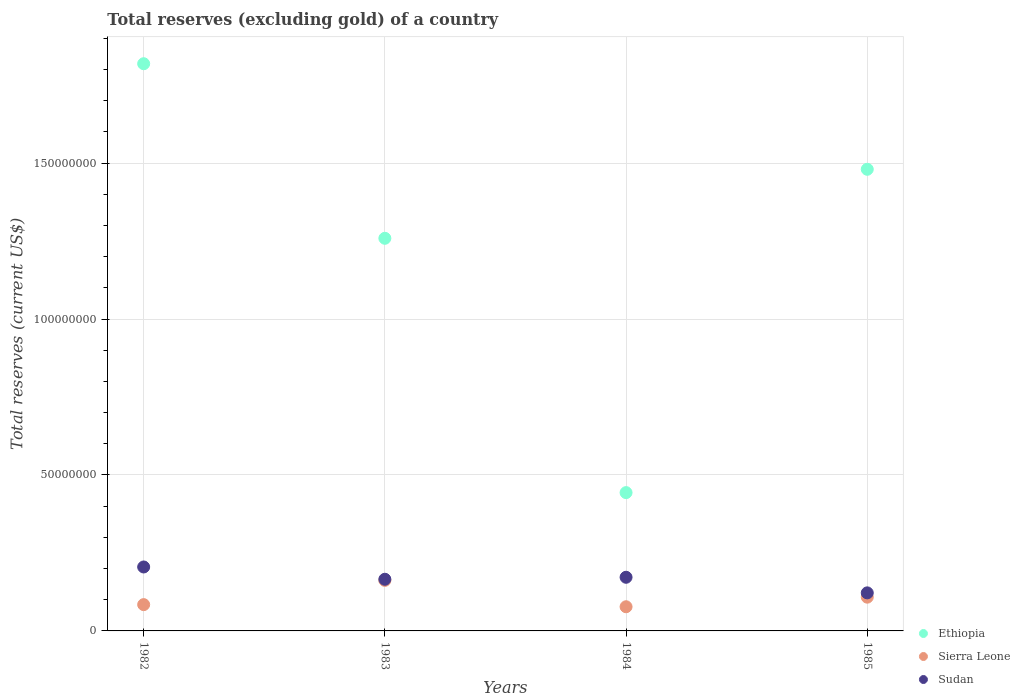How many different coloured dotlines are there?
Ensure brevity in your answer.  3. What is the total reserves (excluding gold) in Ethiopia in 1984?
Provide a succinct answer. 4.43e+07. Across all years, what is the maximum total reserves (excluding gold) in Sudan?
Give a very brief answer. 2.05e+07. Across all years, what is the minimum total reserves (excluding gold) in Sudan?
Provide a succinct answer. 1.22e+07. What is the total total reserves (excluding gold) in Sierra Leone in the graph?
Give a very brief answer. 4.32e+07. What is the difference between the total reserves (excluding gold) in Sudan in 1982 and that in 1984?
Your response must be concise. 3.30e+06. What is the difference between the total reserves (excluding gold) in Ethiopia in 1984 and the total reserves (excluding gold) in Sierra Leone in 1983?
Ensure brevity in your answer.  2.81e+07. What is the average total reserves (excluding gold) in Sierra Leone per year?
Make the answer very short. 1.08e+07. In the year 1982, what is the difference between the total reserves (excluding gold) in Sudan and total reserves (excluding gold) in Sierra Leone?
Ensure brevity in your answer.  1.21e+07. In how many years, is the total reserves (excluding gold) in Ethiopia greater than 110000000 US$?
Ensure brevity in your answer.  3. What is the ratio of the total reserves (excluding gold) in Sudan in 1984 to that in 1985?
Your answer should be compact. 1.41. Is the total reserves (excluding gold) in Ethiopia in 1982 less than that in 1983?
Ensure brevity in your answer.  No. Is the difference between the total reserves (excluding gold) in Sudan in 1983 and 1984 greater than the difference between the total reserves (excluding gold) in Sierra Leone in 1983 and 1984?
Keep it short and to the point. No. What is the difference between the highest and the second highest total reserves (excluding gold) in Sierra Leone?
Keep it short and to the point. 5.38e+06. What is the difference between the highest and the lowest total reserves (excluding gold) in Sudan?
Your answer should be compact. 8.30e+06. Is the sum of the total reserves (excluding gold) in Sudan in 1983 and 1984 greater than the maximum total reserves (excluding gold) in Sierra Leone across all years?
Keep it short and to the point. Yes. Is it the case that in every year, the sum of the total reserves (excluding gold) in Ethiopia and total reserves (excluding gold) in Sierra Leone  is greater than the total reserves (excluding gold) in Sudan?
Provide a succinct answer. Yes. Does the total reserves (excluding gold) in Sudan monotonically increase over the years?
Provide a short and direct response. No. Is the total reserves (excluding gold) in Sierra Leone strictly greater than the total reserves (excluding gold) in Sudan over the years?
Keep it short and to the point. No. How many dotlines are there?
Give a very brief answer. 3. How many years are there in the graph?
Your answer should be very brief. 4. Are the values on the major ticks of Y-axis written in scientific E-notation?
Your answer should be very brief. No. Does the graph contain any zero values?
Offer a terse response. No. Does the graph contain grids?
Give a very brief answer. Yes. Where does the legend appear in the graph?
Make the answer very short. Bottom right. How are the legend labels stacked?
Your response must be concise. Vertical. What is the title of the graph?
Offer a very short reply. Total reserves (excluding gold) of a country. Does "Philippines" appear as one of the legend labels in the graph?
Offer a very short reply. No. What is the label or title of the Y-axis?
Give a very brief answer. Total reserves (current US$). What is the Total reserves (current US$) of Ethiopia in 1982?
Your answer should be very brief. 1.82e+08. What is the Total reserves (current US$) in Sierra Leone in 1982?
Ensure brevity in your answer.  8.43e+06. What is the Total reserves (current US$) of Sudan in 1982?
Provide a succinct answer. 2.05e+07. What is the Total reserves (current US$) of Ethiopia in 1983?
Keep it short and to the point. 1.26e+08. What is the Total reserves (current US$) of Sierra Leone in 1983?
Provide a succinct answer. 1.62e+07. What is the Total reserves (current US$) of Sudan in 1983?
Offer a very short reply. 1.66e+07. What is the Total reserves (current US$) of Ethiopia in 1984?
Provide a succinct answer. 4.43e+07. What is the Total reserves (current US$) of Sierra Leone in 1984?
Your answer should be compact. 7.75e+06. What is the Total reserves (current US$) in Sudan in 1984?
Make the answer very short. 1.72e+07. What is the Total reserves (current US$) in Ethiopia in 1985?
Ensure brevity in your answer.  1.48e+08. What is the Total reserves (current US$) in Sierra Leone in 1985?
Offer a terse response. 1.08e+07. What is the Total reserves (current US$) in Sudan in 1985?
Your response must be concise. 1.22e+07. Across all years, what is the maximum Total reserves (current US$) of Ethiopia?
Offer a very short reply. 1.82e+08. Across all years, what is the maximum Total reserves (current US$) of Sierra Leone?
Ensure brevity in your answer.  1.62e+07. Across all years, what is the maximum Total reserves (current US$) in Sudan?
Ensure brevity in your answer.  2.05e+07. Across all years, what is the minimum Total reserves (current US$) of Ethiopia?
Your answer should be compact. 4.43e+07. Across all years, what is the minimum Total reserves (current US$) of Sierra Leone?
Your answer should be compact. 7.75e+06. Across all years, what is the minimum Total reserves (current US$) in Sudan?
Your answer should be compact. 1.22e+07. What is the total Total reserves (current US$) of Ethiopia in the graph?
Offer a terse response. 5.00e+08. What is the total Total reserves (current US$) in Sierra Leone in the graph?
Keep it short and to the point. 4.32e+07. What is the total Total reserves (current US$) of Sudan in the graph?
Keep it short and to the point. 6.65e+07. What is the difference between the Total reserves (current US$) in Ethiopia in 1982 and that in 1983?
Provide a short and direct response. 5.60e+07. What is the difference between the Total reserves (current US$) of Sierra Leone in 1982 and that in 1983?
Offer a terse response. -7.78e+06. What is the difference between the Total reserves (current US$) in Sudan in 1982 and that in 1983?
Provide a short and direct response. 3.94e+06. What is the difference between the Total reserves (current US$) of Ethiopia in 1982 and that in 1984?
Provide a short and direct response. 1.38e+08. What is the difference between the Total reserves (current US$) in Sierra Leone in 1982 and that in 1984?
Offer a very short reply. 6.80e+05. What is the difference between the Total reserves (current US$) in Sudan in 1982 and that in 1984?
Give a very brief answer. 3.30e+06. What is the difference between the Total reserves (current US$) in Ethiopia in 1982 and that in 1985?
Your answer should be compact. 3.38e+07. What is the difference between the Total reserves (current US$) of Sierra Leone in 1982 and that in 1985?
Give a very brief answer. -2.39e+06. What is the difference between the Total reserves (current US$) of Sudan in 1982 and that in 1985?
Provide a short and direct response. 8.30e+06. What is the difference between the Total reserves (current US$) in Ethiopia in 1983 and that in 1984?
Your answer should be compact. 8.15e+07. What is the difference between the Total reserves (current US$) in Sierra Leone in 1983 and that in 1984?
Provide a short and direct response. 8.46e+06. What is the difference between the Total reserves (current US$) of Sudan in 1983 and that in 1984?
Offer a terse response. -6.37e+05. What is the difference between the Total reserves (current US$) of Ethiopia in 1983 and that in 1985?
Your answer should be very brief. -2.21e+07. What is the difference between the Total reserves (current US$) of Sierra Leone in 1983 and that in 1985?
Provide a short and direct response. 5.38e+06. What is the difference between the Total reserves (current US$) in Sudan in 1983 and that in 1985?
Give a very brief answer. 4.36e+06. What is the difference between the Total reserves (current US$) of Ethiopia in 1984 and that in 1985?
Provide a short and direct response. -1.04e+08. What is the difference between the Total reserves (current US$) of Sierra Leone in 1984 and that in 1985?
Your answer should be compact. -3.07e+06. What is the difference between the Total reserves (current US$) in Ethiopia in 1982 and the Total reserves (current US$) in Sierra Leone in 1983?
Provide a succinct answer. 1.66e+08. What is the difference between the Total reserves (current US$) of Ethiopia in 1982 and the Total reserves (current US$) of Sudan in 1983?
Your response must be concise. 1.65e+08. What is the difference between the Total reserves (current US$) of Sierra Leone in 1982 and the Total reserves (current US$) of Sudan in 1983?
Provide a succinct answer. -8.13e+06. What is the difference between the Total reserves (current US$) of Ethiopia in 1982 and the Total reserves (current US$) of Sierra Leone in 1984?
Keep it short and to the point. 1.74e+08. What is the difference between the Total reserves (current US$) of Ethiopia in 1982 and the Total reserves (current US$) of Sudan in 1984?
Offer a terse response. 1.65e+08. What is the difference between the Total reserves (current US$) of Sierra Leone in 1982 and the Total reserves (current US$) of Sudan in 1984?
Provide a short and direct response. -8.77e+06. What is the difference between the Total reserves (current US$) of Ethiopia in 1982 and the Total reserves (current US$) of Sierra Leone in 1985?
Keep it short and to the point. 1.71e+08. What is the difference between the Total reserves (current US$) in Ethiopia in 1982 and the Total reserves (current US$) in Sudan in 1985?
Offer a very short reply. 1.70e+08. What is the difference between the Total reserves (current US$) of Sierra Leone in 1982 and the Total reserves (current US$) of Sudan in 1985?
Give a very brief answer. -3.77e+06. What is the difference between the Total reserves (current US$) of Ethiopia in 1983 and the Total reserves (current US$) of Sierra Leone in 1984?
Your answer should be compact. 1.18e+08. What is the difference between the Total reserves (current US$) in Ethiopia in 1983 and the Total reserves (current US$) in Sudan in 1984?
Your answer should be compact. 1.09e+08. What is the difference between the Total reserves (current US$) of Sierra Leone in 1983 and the Total reserves (current US$) of Sudan in 1984?
Give a very brief answer. -9.95e+05. What is the difference between the Total reserves (current US$) in Ethiopia in 1983 and the Total reserves (current US$) in Sierra Leone in 1985?
Offer a very short reply. 1.15e+08. What is the difference between the Total reserves (current US$) of Ethiopia in 1983 and the Total reserves (current US$) of Sudan in 1985?
Offer a very short reply. 1.14e+08. What is the difference between the Total reserves (current US$) of Sierra Leone in 1983 and the Total reserves (current US$) of Sudan in 1985?
Provide a succinct answer. 4.00e+06. What is the difference between the Total reserves (current US$) of Ethiopia in 1984 and the Total reserves (current US$) of Sierra Leone in 1985?
Offer a very short reply. 3.35e+07. What is the difference between the Total reserves (current US$) of Ethiopia in 1984 and the Total reserves (current US$) of Sudan in 1985?
Keep it short and to the point. 3.21e+07. What is the difference between the Total reserves (current US$) in Sierra Leone in 1984 and the Total reserves (current US$) in Sudan in 1985?
Offer a very short reply. -4.45e+06. What is the average Total reserves (current US$) in Ethiopia per year?
Provide a short and direct response. 1.25e+08. What is the average Total reserves (current US$) of Sierra Leone per year?
Ensure brevity in your answer.  1.08e+07. What is the average Total reserves (current US$) in Sudan per year?
Your answer should be very brief. 1.66e+07. In the year 1982, what is the difference between the Total reserves (current US$) in Ethiopia and Total reserves (current US$) in Sierra Leone?
Ensure brevity in your answer.  1.73e+08. In the year 1982, what is the difference between the Total reserves (current US$) in Ethiopia and Total reserves (current US$) in Sudan?
Provide a succinct answer. 1.61e+08. In the year 1982, what is the difference between the Total reserves (current US$) in Sierra Leone and Total reserves (current US$) in Sudan?
Ensure brevity in your answer.  -1.21e+07. In the year 1983, what is the difference between the Total reserves (current US$) of Ethiopia and Total reserves (current US$) of Sierra Leone?
Offer a very short reply. 1.10e+08. In the year 1983, what is the difference between the Total reserves (current US$) of Ethiopia and Total reserves (current US$) of Sudan?
Provide a short and direct response. 1.09e+08. In the year 1983, what is the difference between the Total reserves (current US$) in Sierra Leone and Total reserves (current US$) in Sudan?
Give a very brief answer. -3.58e+05. In the year 1984, what is the difference between the Total reserves (current US$) in Ethiopia and Total reserves (current US$) in Sierra Leone?
Ensure brevity in your answer.  3.66e+07. In the year 1984, what is the difference between the Total reserves (current US$) in Ethiopia and Total reserves (current US$) in Sudan?
Offer a terse response. 2.71e+07. In the year 1984, what is the difference between the Total reserves (current US$) in Sierra Leone and Total reserves (current US$) in Sudan?
Give a very brief answer. -9.45e+06. In the year 1985, what is the difference between the Total reserves (current US$) of Ethiopia and Total reserves (current US$) of Sierra Leone?
Ensure brevity in your answer.  1.37e+08. In the year 1985, what is the difference between the Total reserves (current US$) in Ethiopia and Total reserves (current US$) in Sudan?
Make the answer very short. 1.36e+08. In the year 1985, what is the difference between the Total reserves (current US$) in Sierra Leone and Total reserves (current US$) in Sudan?
Keep it short and to the point. -1.38e+06. What is the ratio of the Total reserves (current US$) of Ethiopia in 1982 to that in 1983?
Make the answer very short. 1.44. What is the ratio of the Total reserves (current US$) in Sierra Leone in 1982 to that in 1983?
Offer a terse response. 0.52. What is the ratio of the Total reserves (current US$) of Sudan in 1982 to that in 1983?
Make the answer very short. 1.24. What is the ratio of the Total reserves (current US$) in Ethiopia in 1982 to that in 1984?
Give a very brief answer. 4.1. What is the ratio of the Total reserves (current US$) of Sierra Leone in 1982 to that in 1984?
Provide a succinct answer. 1.09. What is the ratio of the Total reserves (current US$) of Sudan in 1982 to that in 1984?
Provide a succinct answer. 1.19. What is the ratio of the Total reserves (current US$) of Ethiopia in 1982 to that in 1985?
Keep it short and to the point. 1.23. What is the ratio of the Total reserves (current US$) in Sierra Leone in 1982 to that in 1985?
Provide a short and direct response. 0.78. What is the ratio of the Total reserves (current US$) in Sudan in 1982 to that in 1985?
Make the answer very short. 1.68. What is the ratio of the Total reserves (current US$) in Ethiopia in 1983 to that in 1984?
Your answer should be compact. 2.84. What is the ratio of the Total reserves (current US$) in Sierra Leone in 1983 to that in 1984?
Provide a short and direct response. 2.09. What is the ratio of the Total reserves (current US$) of Sudan in 1983 to that in 1984?
Your response must be concise. 0.96. What is the ratio of the Total reserves (current US$) in Ethiopia in 1983 to that in 1985?
Your response must be concise. 0.85. What is the ratio of the Total reserves (current US$) of Sierra Leone in 1983 to that in 1985?
Provide a succinct answer. 1.5. What is the ratio of the Total reserves (current US$) of Sudan in 1983 to that in 1985?
Give a very brief answer. 1.36. What is the ratio of the Total reserves (current US$) of Ethiopia in 1984 to that in 1985?
Offer a terse response. 0.3. What is the ratio of the Total reserves (current US$) in Sierra Leone in 1984 to that in 1985?
Your answer should be compact. 0.72. What is the ratio of the Total reserves (current US$) in Sudan in 1984 to that in 1985?
Provide a short and direct response. 1.41. What is the difference between the highest and the second highest Total reserves (current US$) of Ethiopia?
Keep it short and to the point. 3.38e+07. What is the difference between the highest and the second highest Total reserves (current US$) in Sierra Leone?
Your response must be concise. 5.38e+06. What is the difference between the highest and the second highest Total reserves (current US$) in Sudan?
Keep it short and to the point. 3.30e+06. What is the difference between the highest and the lowest Total reserves (current US$) in Ethiopia?
Your answer should be compact. 1.38e+08. What is the difference between the highest and the lowest Total reserves (current US$) in Sierra Leone?
Offer a very short reply. 8.46e+06. What is the difference between the highest and the lowest Total reserves (current US$) of Sudan?
Your answer should be compact. 8.30e+06. 